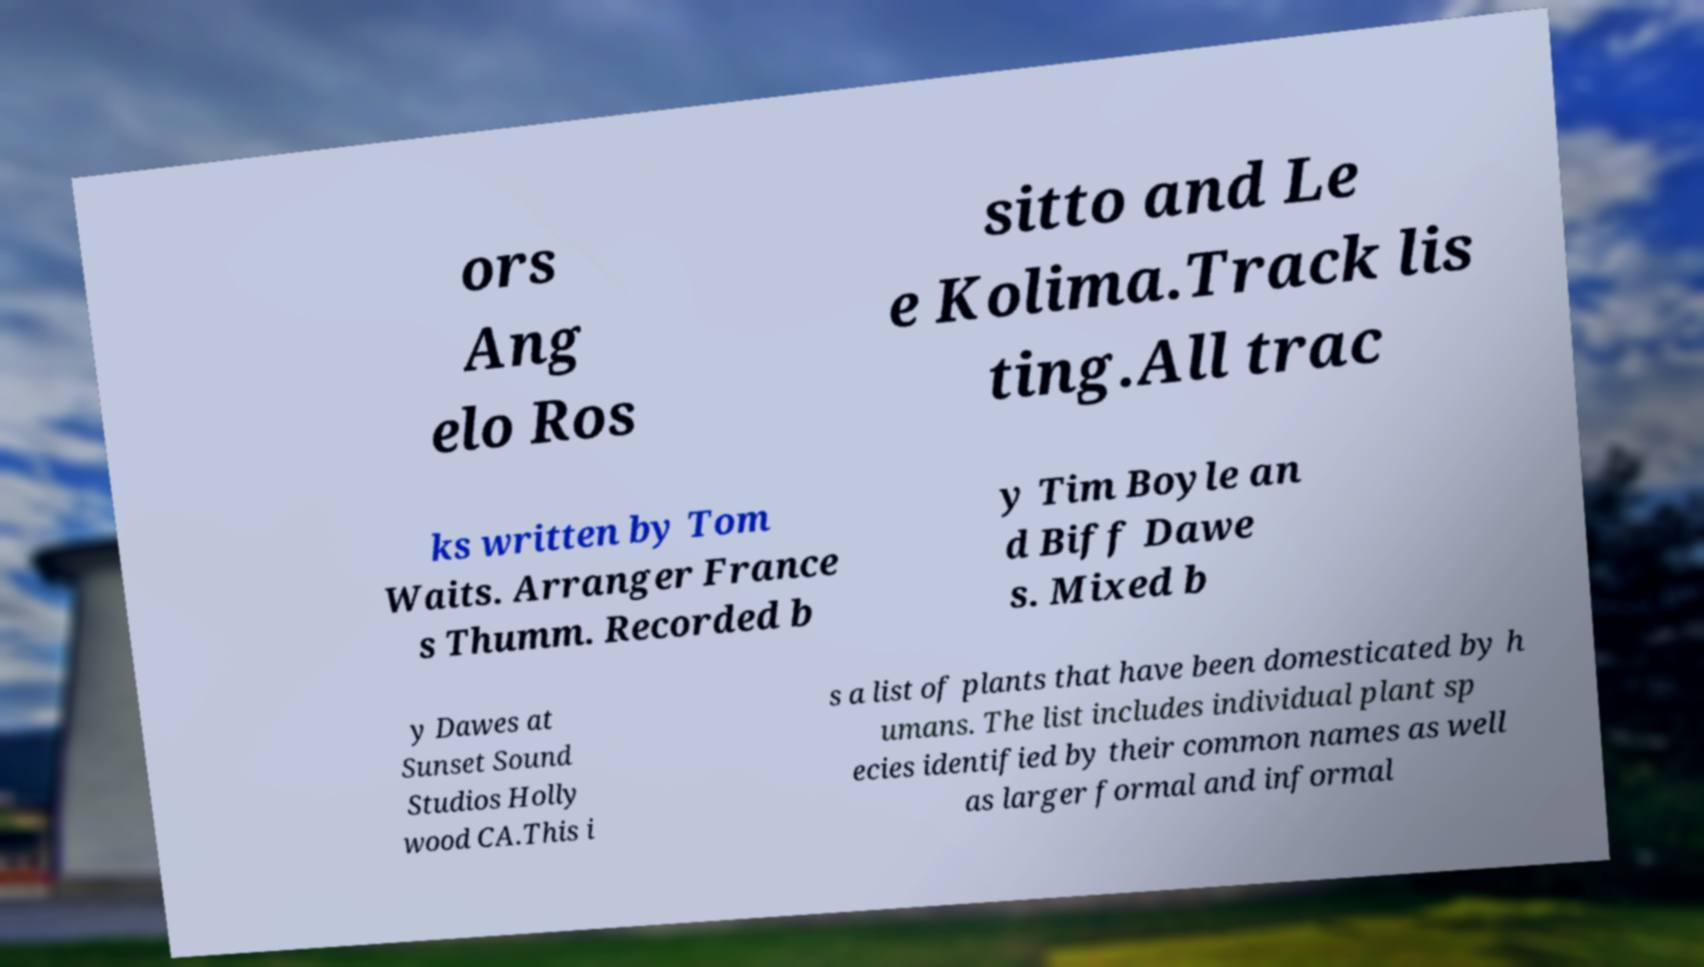Could you extract and type out the text from this image? ors Ang elo Ros sitto and Le e Kolima.Track lis ting.All trac ks written by Tom Waits. Arranger France s Thumm. Recorded b y Tim Boyle an d Biff Dawe s. Mixed b y Dawes at Sunset Sound Studios Holly wood CA.This i s a list of plants that have been domesticated by h umans. The list includes individual plant sp ecies identified by their common names as well as larger formal and informal 